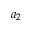<formula> <loc_0><loc_0><loc_500><loc_500>a _ { 2 }</formula> 